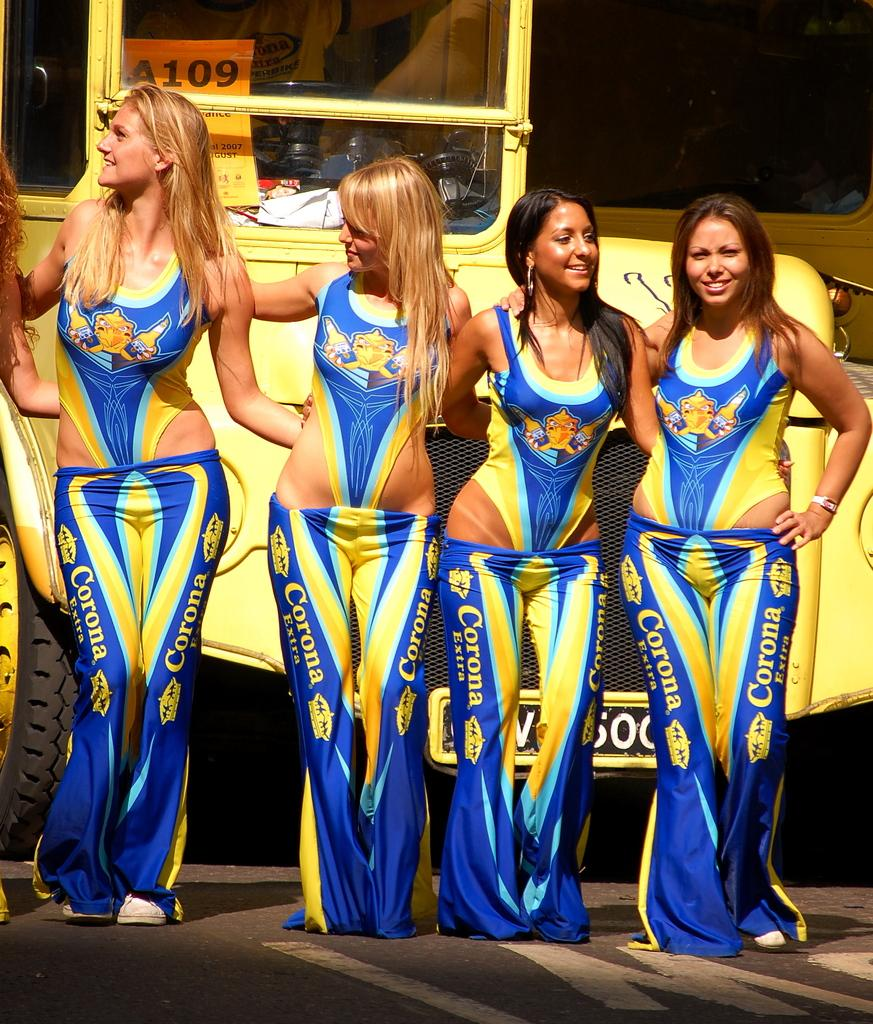Provide a one-sentence caption for the provided image. Four girls in bathing suits are wearing low-rise Corona pants. 